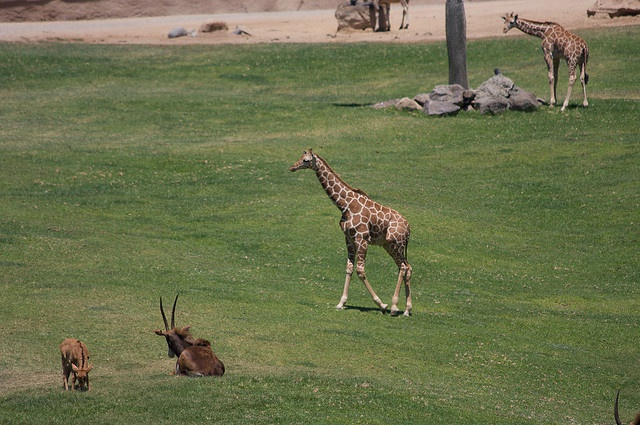Describe the objects in this image and their specific colors. I can see giraffe in brown, black, and gray tones, giraffe in brown, gray, black, and darkgray tones, and giraffe in brown, gray, maroon, and darkgray tones in this image. 